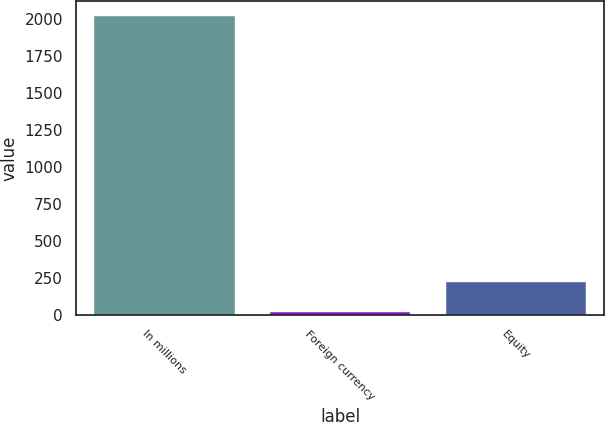<chart> <loc_0><loc_0><loc_500><loc_500><bar_chart><fcel>In millions<fcel>Foreign currency<fcel>Equity<nl><fcel>2017<fcel>24.2<fcel>223.48<nl></chart> 